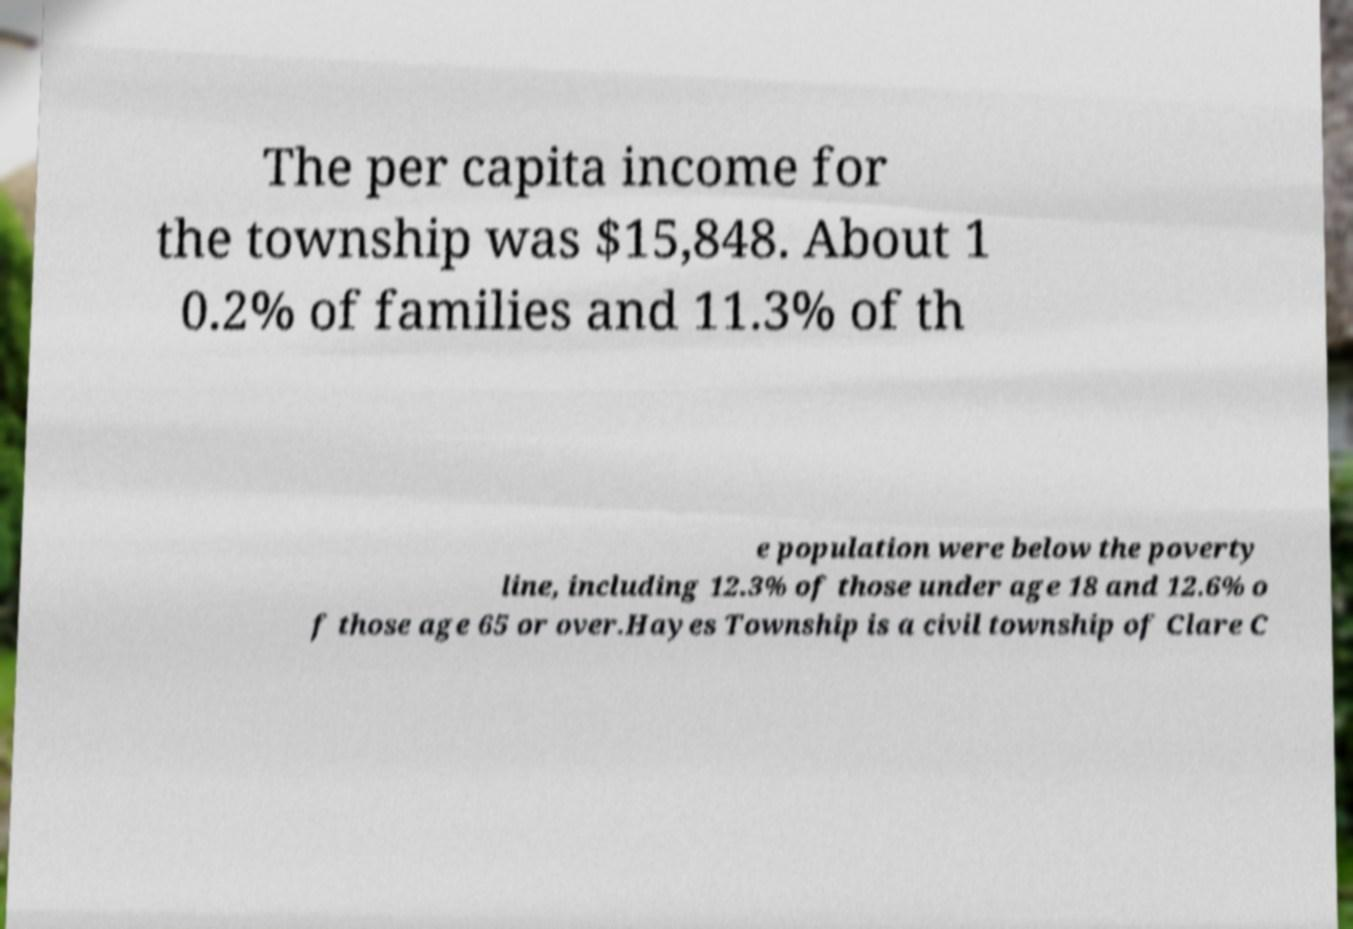Please identify and transcribe the text found in this image. The per capita income for the township was $15,848. About 1 0.2% of families and 11.3% of th e population were below the poverty line, including 12.3% of those under age 18 and 12.6% o f those age 65 or over.Hayes Township is a civil township of Clare C 